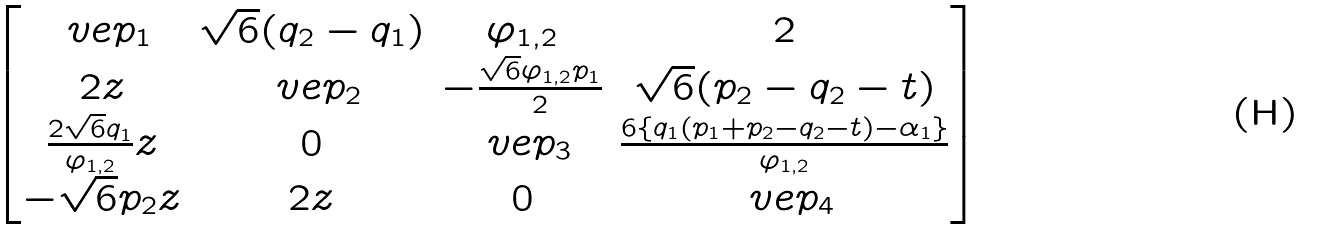<formula> <loc_0><loc_0><loc_500><loc_500>\begin{bmatrix} \ v e p _ { 1 } & \sqrt { 6 } ( q _ { 2 } - q _ { 1 } ) & \varphi _ { 1 , 2 } & 2 \\ 2 z & \ v e p _ { 2 } & - \frac { \sqrt { 6 } \varphi _ { 1 , 2 } p _ { 1 } } { 2 } & \sqrt { 6 } ( p _ { 2 } - q _ { 2 } - t ) \\ \frac { 2 \sqrt { 6 } q _ { 1 } } { \varphi _ { 1 , 2 } } z & 0 & \ v e p _ { 3 } & \frac { 6 \{ q _ { 1 } ( p _ { 1 } + p _ { 2 } - q _ { 2 } - t ) - \alpha _ { 1 } \} } { \varphi _ { 1 , 2 } } \\ - \sqrt { 6 } p _ { 2 } z & 2 z & 0 & \ v e p _ { 4 } \end{bmatrix}</formula> 